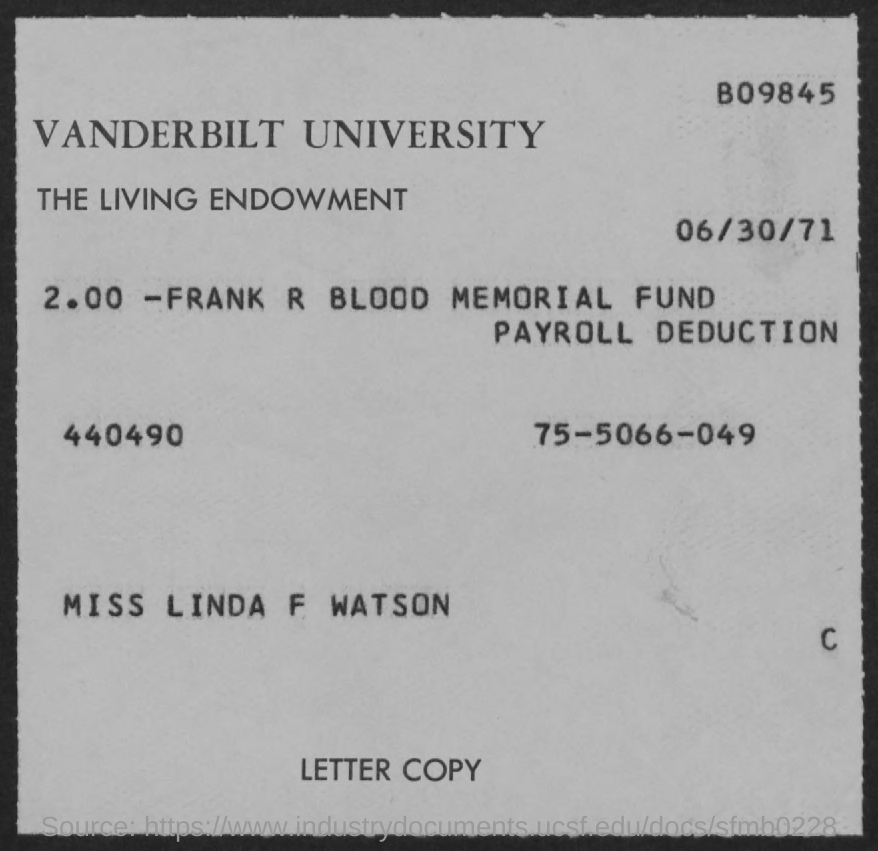Which University is mentioned in the document?
Make the answer very short. VANDERBILT UNIVERSITY. What is the date mentioned in this document?
Ensure brevity in your answer.  06/30/71. 